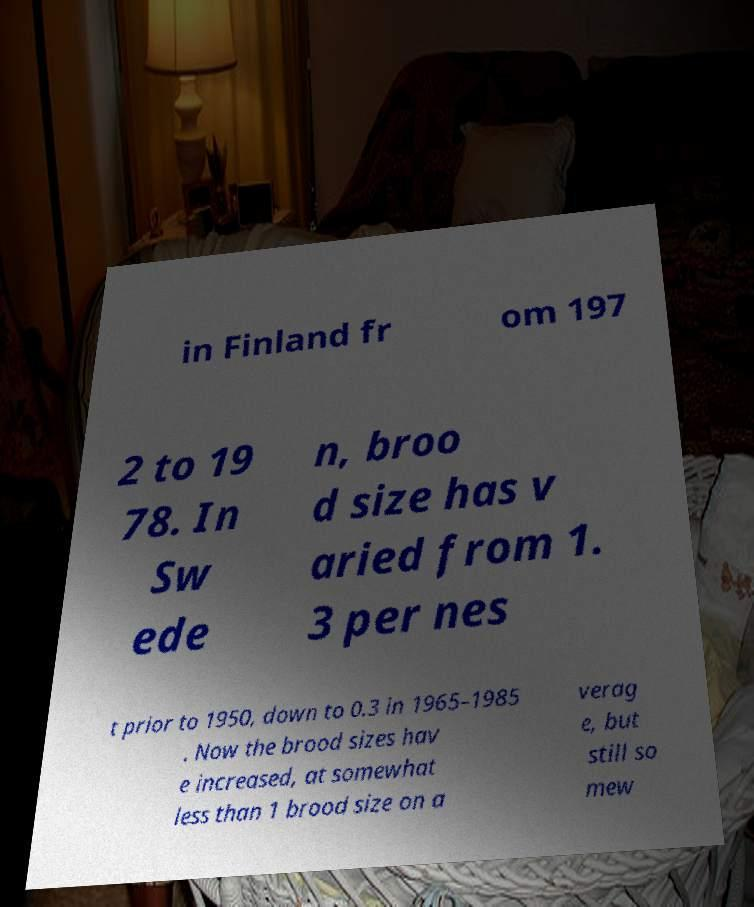Can you accurately transcribe the text from the provided image for me? in Finland fr om 197 2 to 19 78. In Sw ede n, broo d size has v aried from 1. 3 per nes t prior to 1950, down to 0.3 in 1965–1985 . Now the brood sizes hav e increased, at somewhat less than 1 brood size on a verag e, but still so mew 